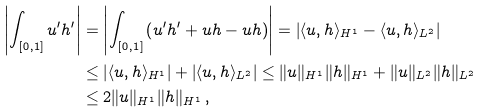Convert formula to latex. <formula><loc_0><loc_0><loc_500><loc_500>\left | \int _ { [ 0 , 1 ] } u ^ { \prime } h ^ { \prime } \right | & = \left | \int _ { [ 0 , 1 ] } \left ( u ^ { \prime } h ^ { \prime } + u h - u h \right ) \right | = \left | \langle u , h \rangle _ { H ^ { 1 } } - \langle u , h \rangle _ { L ^ { 2 } } \right | \\ & \leq \left | \langle u , h \rangle _ { H ^ { 1 } } \right | + \left | \langle u , h \rangle _ { L ^ { 2 } } \right | \leq \| u \| _ { H ^ { 1 } } \| h \| _ { H ^ { 1 } } + \| u \| _ { L ^ { 2 } } \| h \| _ { L ^ { 2 } } \\ & \leq 2 \| u \| _ { H ^ { 1 } } \| h \| _ { H ^ { 1 } } \, ,</formula> 